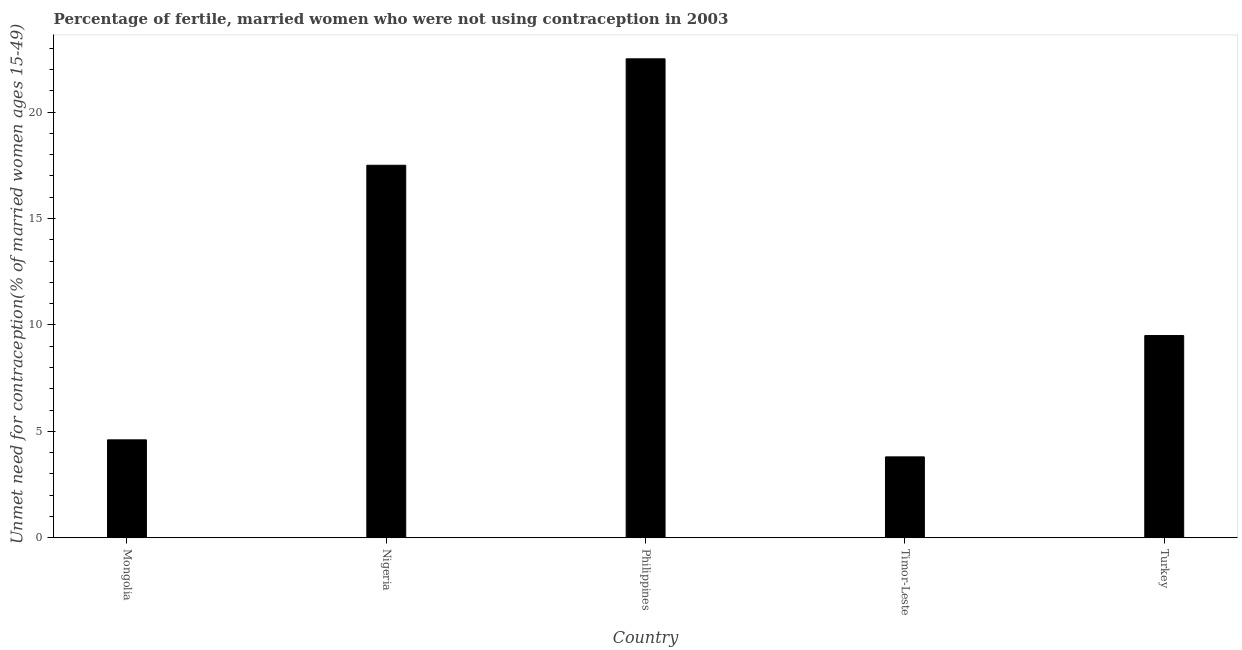What is the title of the graph?
Provide a short and direct response. Percentage of fertile, married women who were not using contraception in 2003. What is the label or title of the X-axis?
Provide a succinct answer. Country. What is the label or title of the Y-axis?
Keep it short and to the point.  Unmet need for contraception(% of married women ages 15-49). What is the number of married women who are not using contraception in Philippines?
Provide a succinct answer. 22.5. In which country was the number of married women who are not using contraception maximum?
Make the answer very short. Philippines. In which country was the number of married women who are not using contraception minimum?
Offer a very short reply. Timor-Leste. What is the sum of the number of married women who are not using contraception?
Provide a succinct answer. 57.9. What is the average number of married women who are not using contraception per country?
Offer a terse response. 11.58. In how many countries, is the number of married women who are not using contraception greater than 1 %?
Provide a succinct answer. 5. What is the ratio of the number of married women who are not using contraception in Nigeria to that in Philippines?
Keep it short and to the point. 0.78. How many countries are there in the graph?
Your response must be concise. 5. What is the difference between two consecutive major ticks on the Y-axis?
Ensure brevity in your answer.  5. What is the  Unmet need for contraception(% of married women ages 15-49) in Mongolia?
Your answer should be compact. 4.6. What is the  Unmet need for contraception(% of married women ages 15-49) in Timor-Leste?
Keep it short and to the point. 3.8. What is the difference between the  Unmet need for contraception(% of married women ages 15-49) in Mongolia and Philippines?
Make the answer very short. -17.9. What is the difference between the  Unmet need for contraception(% of married women ages 15-49) in Mongolia and Turkey?
Give a very brief answer. -4.9. What is the difference between the  Unmet need for contraception(% of married women ages 15-49) in Nigeria and Timor-Leste?
Your answer should be very brief. 13.7. What is the difference between the  Unmet need for contraception(% of married women ages 15-49) in Philippines and Turkey?
Offer a very short reply. 13. What is the difference between the  Unmet need for contraception(% of married women ages 15-49) in Timor-Leste and Turkey?
Give a very brief answer. -5.7. What is the ratio of the  Unmet need for contraception(% of married women ages 15-49) in Mongolia to that in Nigeria?
Make the answer very short. 0.26. What is the ratio of the  Unmet need for contraception(% of married women ages 15-49) in Mongolia to that in Philippines?
Make the answer very short. 0.2. What is the ratio of the  Unmet need for contraception(% of married women ages 15-49) in Mongolia to that in Timor-Leste?
Offer a very short reply. 1.21. What is the ratio of the  Unmet need for contraception(% of married women ages 15-49) in Mongolia to that in Turkey?
Keep it short and to the point. 0.48. What is the ratio of the  Unmet need for contraception(% of married women ages 15-49) in Nigeria to that in Philippines?
Make the answer very short. 0.78. What is the ratio of the  Unmet need for contraception(% of married women ages 15-49) in Nigeria to that in Timor-Leste?
Your answer should be very brief. 4.61. What is the ratio of the  Unmet need for contraception(% of married women ages 15-49) in Nigeria to that in Turkey?
Keep it short and to the point. 1.84. What is the ratio of the  Unmet need for contraception(% of married women ages 15-49) in Philippines to that in Timor-Leste?
Your answer should be compact. 5.92. What is the ratio of the  Unmet need for contraception(% of married women ages 15-49) in Philippines to that in Turkey?
Offer a very short reply. 2.37. What is the ratio of the  Unmet need for contraception(% of married women ages 15-49) in Timor-Leste to that in Turkey?
Give a very brief answer. 0.4. 